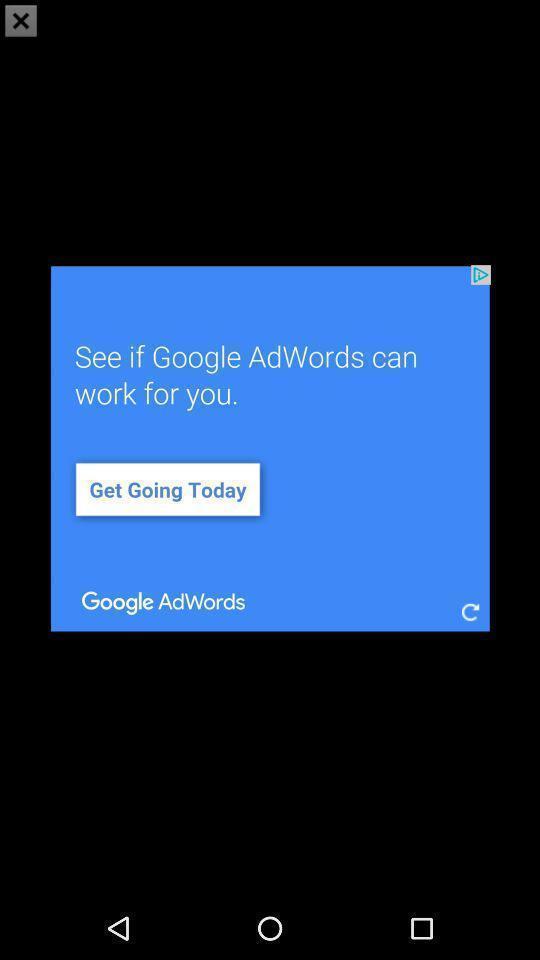Describe the visual elements of this screenshot. Pop-up showing notification page. 